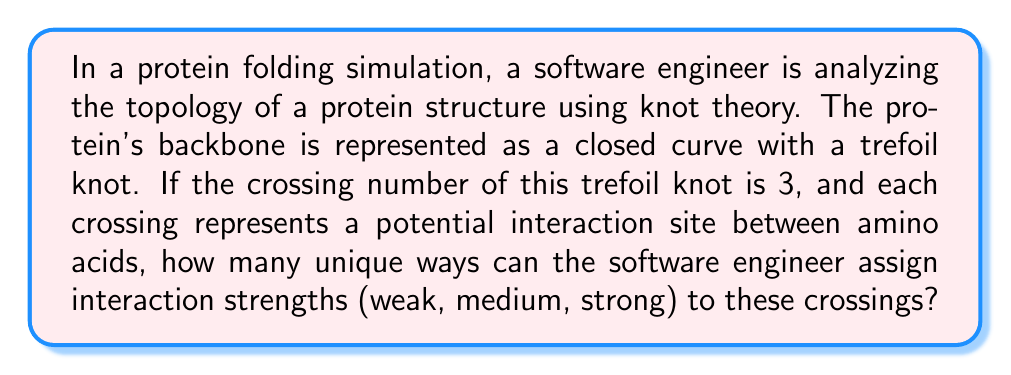Give your solution to this math problem. Let's approach this problem step-by-step:

1) First, we need to understand what the question is asking:
   - We have a trefoil knot representing a protein structure
   - The crossing number of this knot is 3
   - Each crossing can be assigned one of three interaction strengths: weak, medium, or strong

2) This is essentially a combinatorial problem. We need to find out in how many ways we can assign 3 different options to 3 different positions.

3) This type of problem can be solved using the multiplication principle of counting.

4) For the first crossing, we have 3 choices (weak, medium, strong).

5) For the second crossing, we again have 3 choices.

6) For the third crossing, we still have 3 choices.

7) Therefore, the total number of ways to assign the interaction strengths is:

   $$3 \times 3 \times 3 = 3^3 = 27$$

8) This result can also be interpreted as the number of functions from a set of size 3 (the crossings) to another set of size 3 (the interaction strengths), which is always $3^3$ in this case.

9) In terms of knot theory and protein folding, this represents the number of different interaction patterns that could potentially occur at the crossings of the trefoil knot, which could correspond to different folding behaviors or stable conformations of the protein.
Answer: 27 